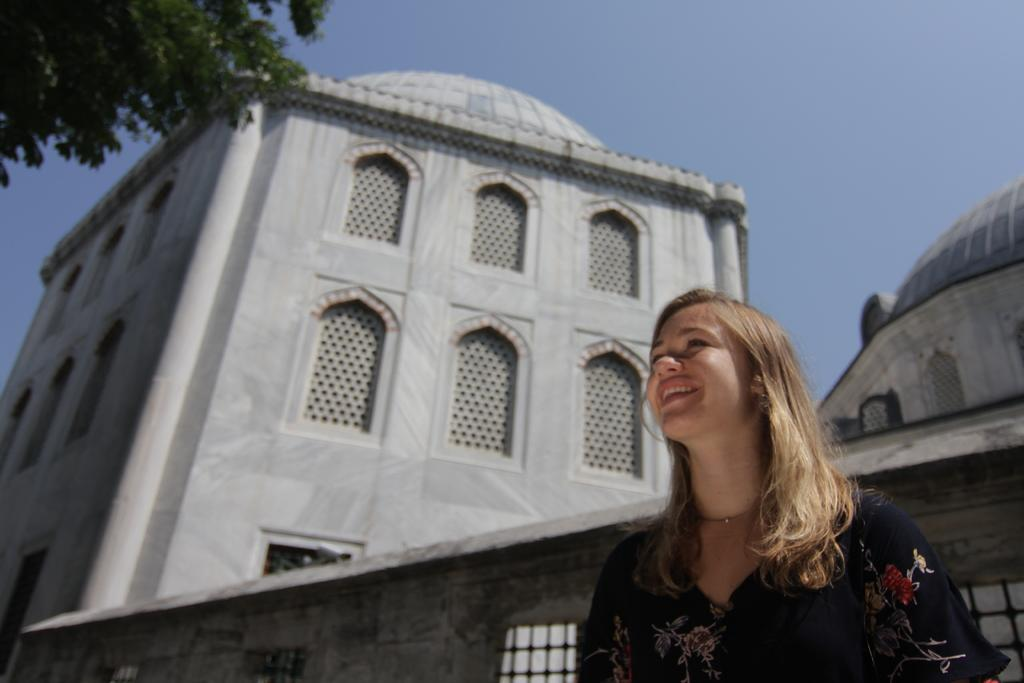Who is present in the image? There is a woman in the image. What is the woman wearing? The woman is wearing a black dress. What expression does the woman have? The woman is smiling. What can be seen behind the woman? There is a building behind the woman. What is located in the left top corner of the image? There is a tree in the left top corner of the image. What type of morning offer does the woman have in the image? There is no mention of a morning offer or any type of offer in the image. The image only shows a woman wearing a black dress, smiling, with a building in the background and a tree in the left top corner. 